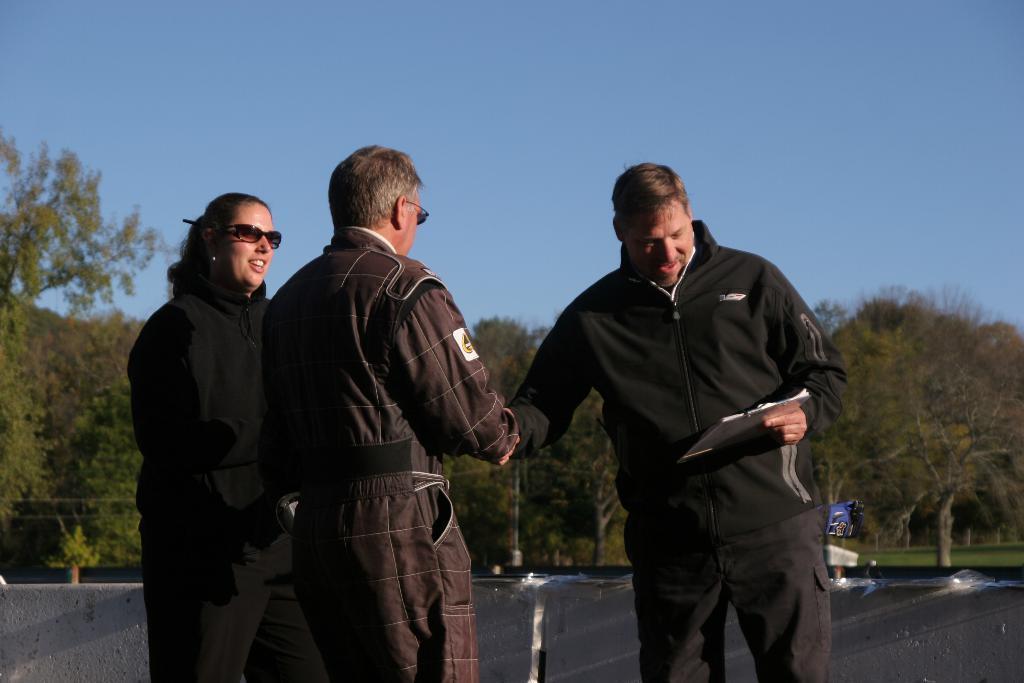Could you give a brief overview of what you see in this image? In this image there are three persons wearing jackets are standing before a wall. A person wearing a black jacket is holding a pad in his hand. Woman is wearing goggles. Behind them there is grassland having few trees. Top of image there is sky. 